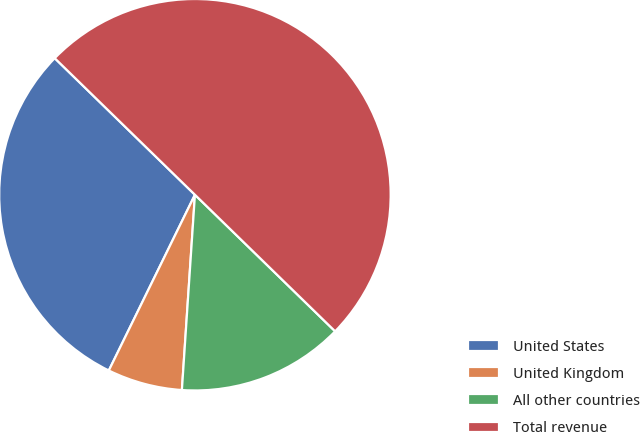Convert chart to OTSL. <chart><loc_0><loc_0><loc_500><loc_500><pie_chart><fcel>United States<fcel>United Kingdom<fcel>All other countries<fcel>Total revenue<nl><fcel>30.04%<fcel>6.19%<fcel>13.77%<fcel>50.0%<nl></chart> 